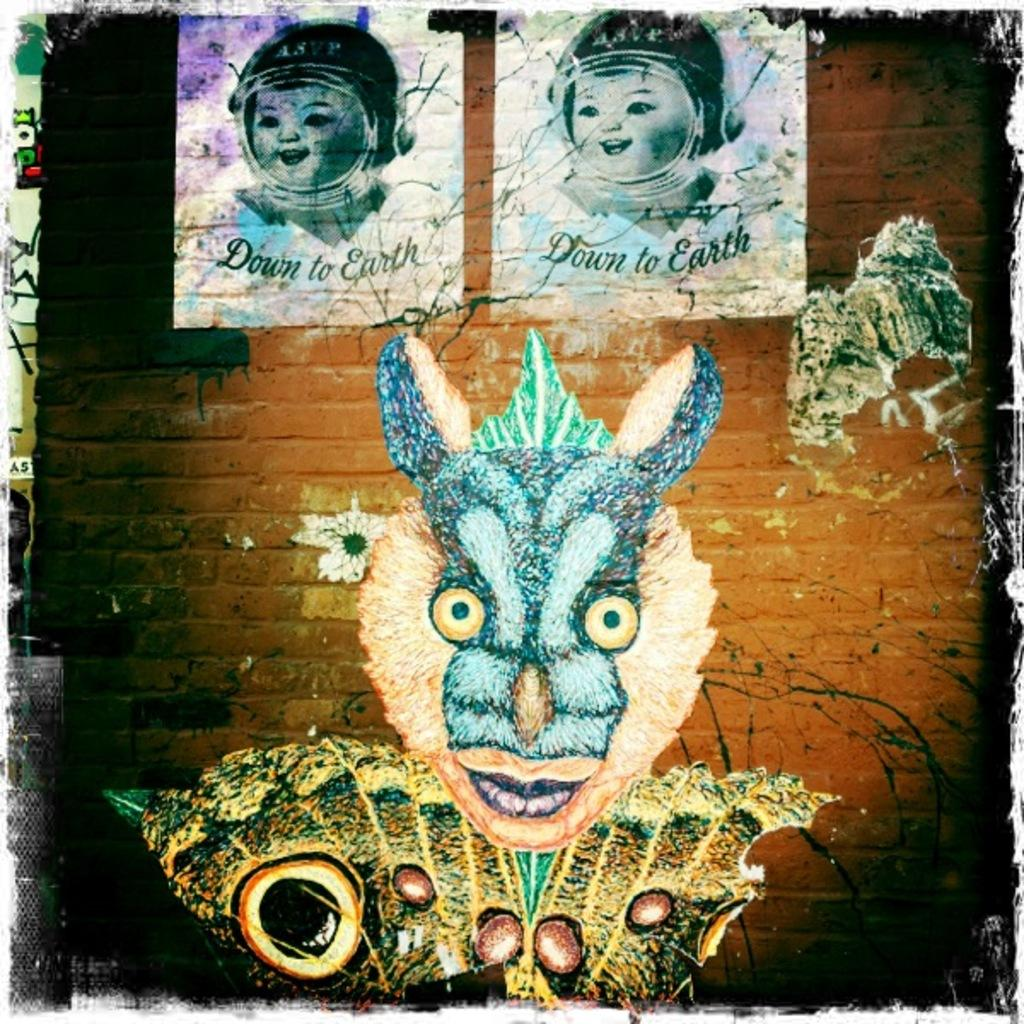What type of editing has been done to the image? The image is edited, but the specific type of editing is not mentioned in the facts. What can be seen in the edited image? There are pictures and text visible in the image. What is the background of the image? There is a wall in the image. How does the stranger in the image make the decision to comfort the person? There is no stranger or person present in the image, so it is not possible to answer this question. 